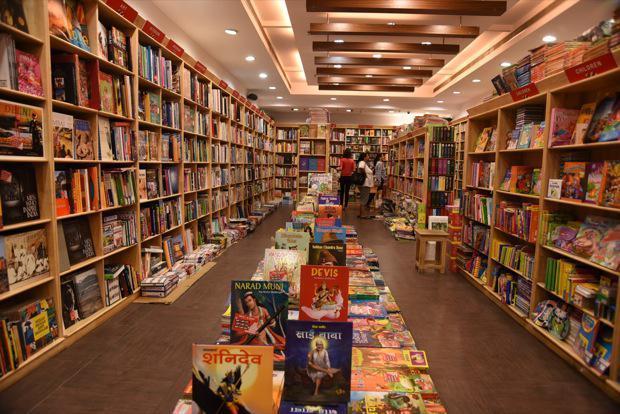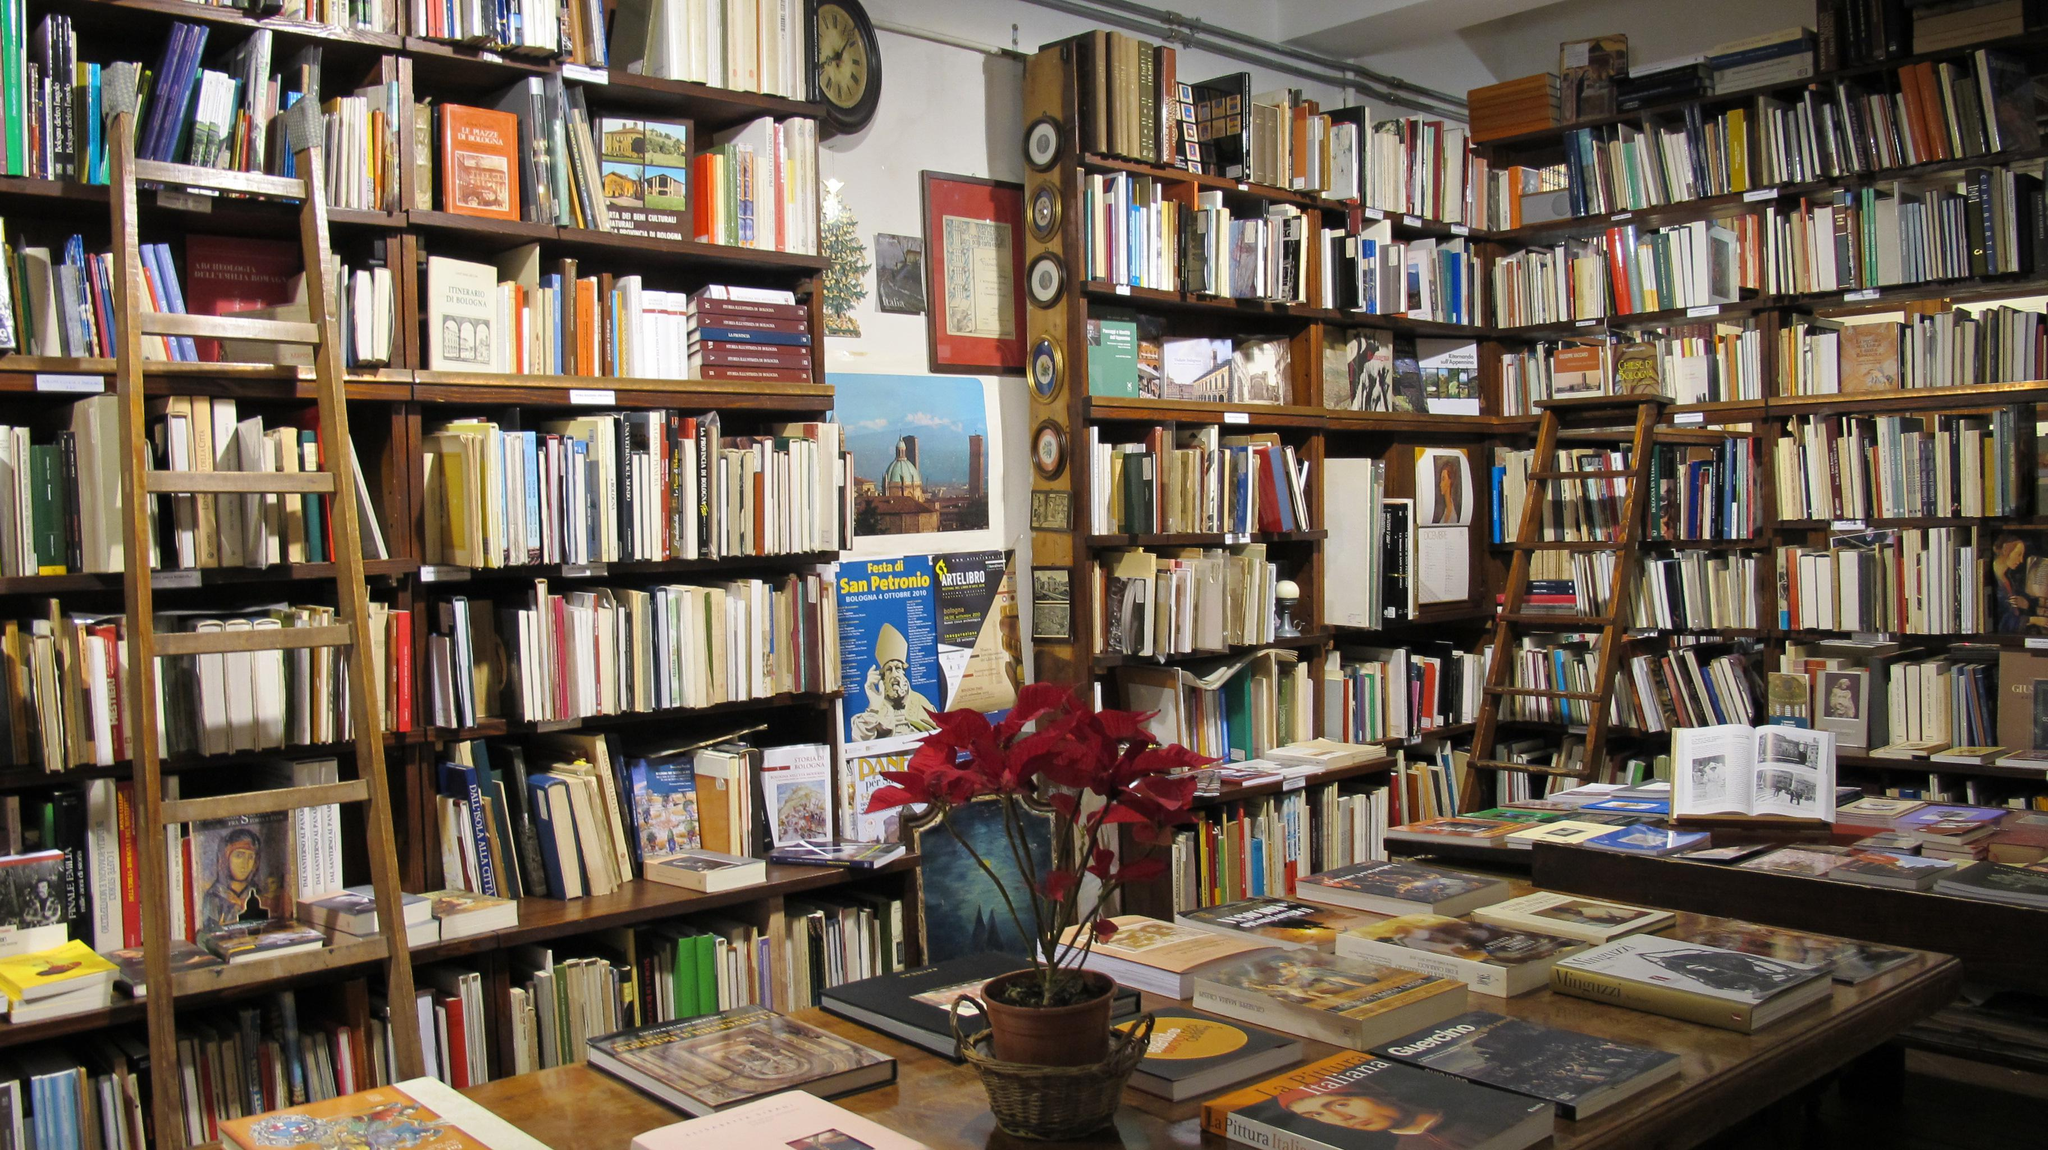The first image is the image on the left, the second image is the image on the right. Examine the images to the left and right. Is the description "There are at least two people in the image on the left." accurate? Answer yes or no. Yes. 